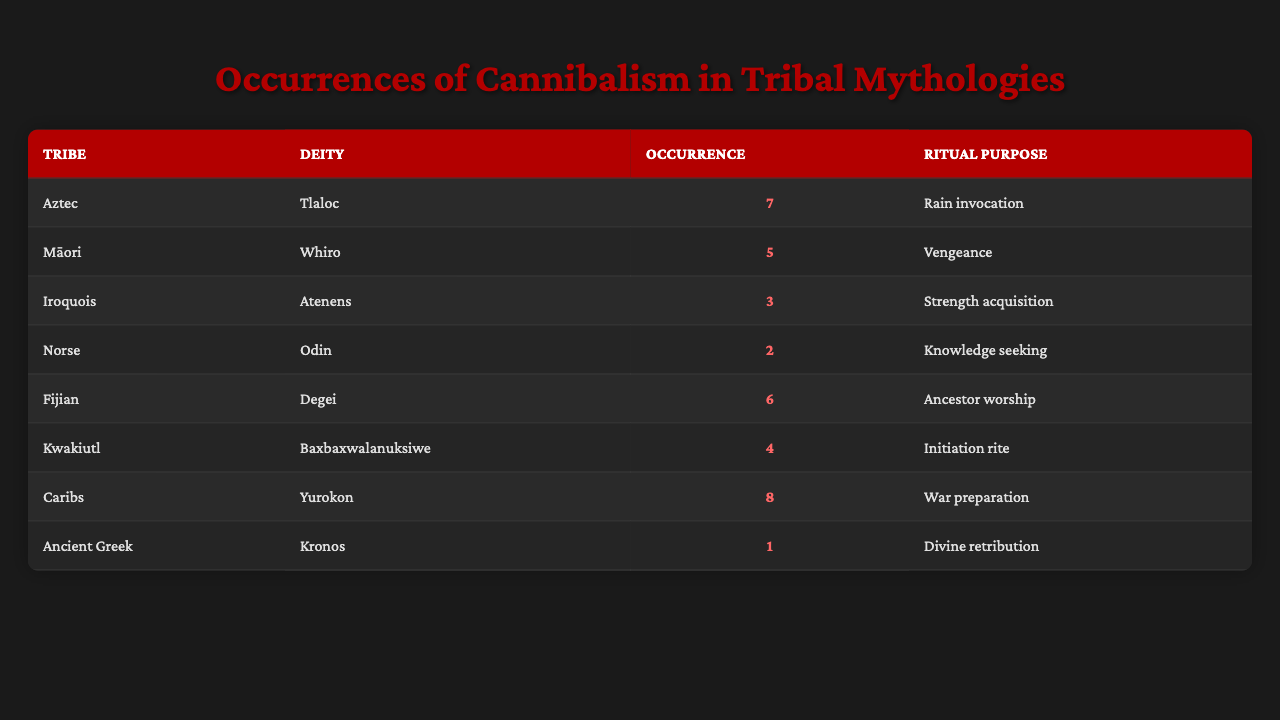What tribe had the highest occurrence of cannibalism? The table shows the occurrences of cannibalism per tribe, with the Caribs having the highest occurrence at 8.
Answer: Caribs Which deity is associated with the purpose of ancestor worship? According to the table, the deity Degei from the Fijian tribe is related to ancestor worship with 6 occurrences.
Answer: Degei What is the total number of occurrences of cannibalism by the Aztec tribe and the Māori tribe combined? Adding the occurrences from the Aztec tribe (7) and the Māori tribe (5) gives a total of 12 occurrences.
Answer: 12 Is it true that the Iroquois deity Atenens has more occurrences of cannibalism than the Norse deity Odin? The Iroquois deity Atenens has 3 occurrences, while Odin has 2 occurrences; therefore, Atenens has more occurrences than Odin.
Answer: Yes Calculate the average occurrence of cannibalism across all tribes in the table. First, sum the occurrences: 7 + 5 + 3 + 2 + 6 + 4 + 8 + 1 = 36. There are 8 tribes, so the average is 36 divided by 8, which equals 4.5.
Answer: 4.5 Which tribe performed cannibalism rituals for war preparation? The table indicates that the Caribs performed cannibalism as part of war preparation with 8 occurrences.
Answer: Caribs Which ritual purpose is associated with the least number of occurrences? The table shows that the Ancient Greek tribe with the deity Kronos has the least occurrences at 1, associated with divine retribution.
Answer: Divine retribution How many tribes have an occurrence count of 5 or more? The tribes with 5 or more occurrences are the Aztec (7), Māori (5), Fijian (6), and Caribs (8), making a total of 4 tribes.
Answer: 4 What is the difference in cannibalism occurrences between the Caribs and the Aztec tribe? The Caribs have 8 occurrences, while the Aztec tribe has 7; the difference is 8 - 7 = 1 occurrence.
Answer: 1 Is there a tribe that has the same ritual purpose as the Ancient Greek tribe for a higher occurrence? Yes, the deity Tlaloc of the Aztec tribe also involves a cannibalism ritual for rain invocation and has a higher occurrence count of 7 compared to the 1 occurrence of Kronos.
Answer: Yes 